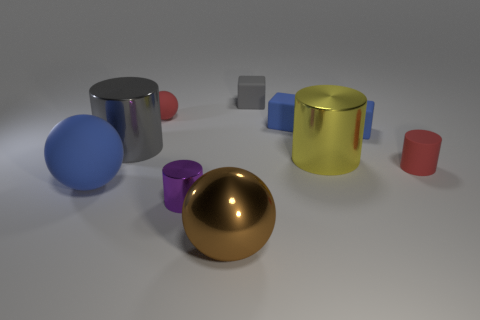Is the color of the small rubber cylinder the same as the tiny rubber ball?
Give a very brief answer. Yes. There is a tiny cylinder that is the same color as the small matte ball; what is it made of?
Offer a terse response. Rubber. Is there any other thing that has the same shape as the brown thing?
Give a very brief answer. Yes. There is a blue sphere behind the large brown thing; what is it made of?
Your response must be concise. Rubber. Is the gray thing left of the brown object made of the same material as the red ball?
Provide a short and direct response. No. How many things are either large yellow objects or rubber objects that are behind the tiny matte cylinder?
Make the answer very short. 5. What is the size of the red rubber object that is the same shape as the big gray object?
Keep it short and to the point. Small. Is there anything else that is the same size as the brown metal thing?
Make the answer very short. Yes. There is a big gray thing; are there any big spheres behind it?
Provide a succinct answer. No. Does the large shiny cylinder on the left side of the small purple cylinder have the same color as the rubber sphere that is in front of the rubber cylinder?
Your answer should be very brief. No. 